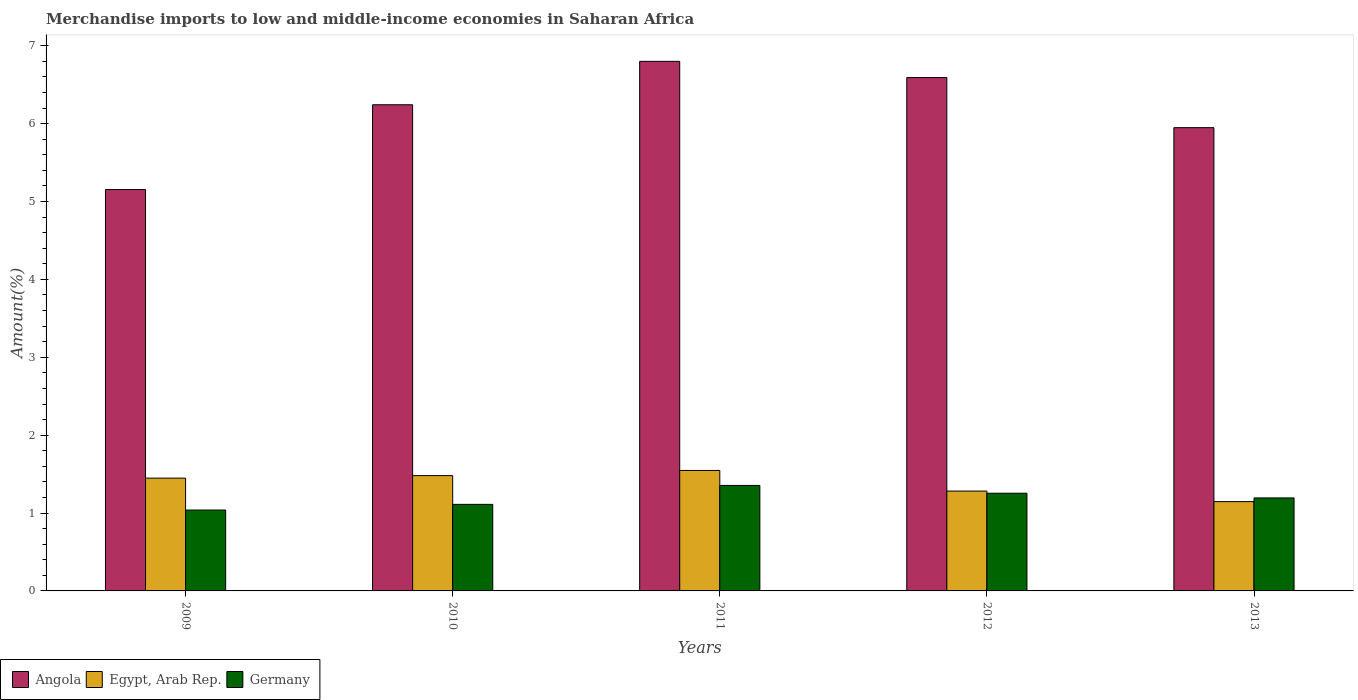How many different coloured bars are there?
Your answer should be very brief. 3. How many groups of bars are there?
Your response must be concise. 5. Are the number of bars per tick equal to the number of legend labels?
Keep it short and to the point. Yes. How many bars are there on the 1st tick from the left?
Offer a very short reply. 3. What is the percentage of amount earned from merchandise imports in Egypt, Arab Rep. in 2011?
Offer a very short reply. 1.55. Across all years, what is the maximum percentage of amount earned from merchandise imports in Egypt, Arab Rep.?
Offer a very short reply. 1.55. Across all years, what is the minimum percentage of amount earned from merchandise imports in Angola?
Keep it short and to the point. 5.15. What is the total percentage of amount earned from merchandise imports in Angola in the graph?
Provide a succinct answer. 30.74. What is the difference between the percentage of amount earned from merchandise imports in Angola in 2010 and that in 2012?
Your answer should be compact. -0.35. What is the difference between the percentage of amount earned from merchandise imports in Germany in 2011 and the percentage of amount earned from merchandise imports in Angola in 2009?
Make the answer very short. -3.8. What is the average percentage of amount earned from merchandise imports in Egypt, Arab Rep. per year?
Give a very brief answer. 1.38. In the year 2010, what is the difference between the percentage of amount earned from merchandise imports in Egypt, Arab Rep. and percentage of amount earned from merchandise imports in Germany?
Give a very brief answer. 0.37. What is the ratio of the percentage of amount earned from merchandise imports in Germany in 2009 to that in 2013?
Provide a succinct answer. 0.87. What is the difference between the highest and the second highest percentage of amount earned from merchandise imports in Angola?
Offer a very short reply. 0.21. What is the difference between the highest and the lowest percentage of amount earned from merchandise imports in Egypt, Arab Rep.?
Ensure brevity in your answer.  0.4. In how many years, is the percentage of amount earned from merchandise imports in Angola greater than the average percentage of amount earned from merchandise imports in Angola taken over all years?
Your response must be concise. 3. What does the 2nd bar from the left in 2012 represents?
Offer a terse response. Egypt, Arab Rep. Does the graph contain any zero values?
Your answer should be very brief. No. What is the title of the graph?
Make the answer very short. Merchandise imports to low and middle-income economies in Saharan Africa. Does "Pacific island small states" appear as one of the legend labels in the graph?
Provide a succinct answer. No. What is the label or title of the X-axis?
Keep it short and to the point. Years. What is the label or title of the Y-axis?
Make the answer very short. Amount(%). What is the Amount(%) of Angola in 2009?
Your answer should be very brief. 5.15. What is the Amount(%) in Egypt, Arab Rep. in 2009?
Ensure brevity in your answer.  1.45. What is the Amount(%) of Germany in 2009?
Your answer should be compact. 1.04. What is the Amount(%) of Angola in 2010?
Your response must be concise. 6.24. What is the Amount(%) of Egypt, Arab Rep. in 2010?
Offer a terse response. 1.48. What is the Amount(%) in Germany in 2010?
Provide a succinct answer. 1.11. What is the Amount(%) of Angola in 2011?
Your answer should be compact. 6.8. What is the Amount(%) in Egypt, Arab Rep. in 2011?
Your response must be concise. 1.55. What is the Amount(%) of Germany in 2011?
Offer a terse response. 1.35. What is the Amount(%) in Angola in 2012?
Your answer should be compact. 6.59. What is the Amount(%) in Egypt, Arab Rep. in 2012?
Offer a terse response. 1.28. What is the Amount(%) in Germany in 2012?
Keep it short and to the point. 1.25. What is the Amount(%) of Angola in 2013?
Offer a terse response. 5.95. What is the Amount(%) of Egypt, Arab Rep. in 2013?
Keep it short and to the point. 1.15. What is the Amount(%) of Germany in 2013?
Ensure brevity in your answer.  1.19. Across all years, what is the maximum Amount(%) in Angola?
Offer a very short reply. 6.8. Across all years, what is the maximum Amount(%) of Egypt, Arab Rep.?
Your response must be concise. 1.55. Across all years, what is the maximum Amount(%) in Germany?
Ensure brevity in your answer.  1.35. Across all years, what is the minimum Amount(%) in Angola?
Keep it short and to the point. 5.15. Across all years, what is the minimum Amount(%) in Egypt, Arab Rep.?
Provide a short and direct response. 1.15. Across all years, what is the minimum Amount(%) in Germany?
Provide a succinct answer. 1.04. What is the total Amount(%) in Angola in the graph?
Ensure brevity in your answer.  30.74. What is the total Amount(%) of Egypt, Arab Rep. in the graph?
Make the answer very short. 6.91. What is the total Amount(%) of Germany in the graph?
Give a very brief answer. 5.95. What is the difference between the Amount(%) in Angola in 2009 and that in 2010?
Your answer should be compact. -1.09. What is the difference between the Amount(%) of Egypt, Arab Rep. in 2009 and that in 2010?
Give a very brief answer. -0.03. What is the difference between the Amount(%) in Germany in 2009 and that in 2010?
Provide a short and direct response. -0.07. What is the difference between the Amount(%) of Angola in 2009 and that in 2011?
Offer a very short reply. -1.65. What is the difference between the Amount(%) of Egypt, Arab Rep. in 2009 and that in 2011?
Your answer should be compact. -0.1. What is the difference between the Amount(%) in Germany in 2009 and that in 2011?
Offer a terse response. -0.32. What is the difference between the Amount(%) in Angola in 2009 and that in 2012?
Your answer should be compact. -1.44. What is the difference between the Amount(%) in Egypt, Arab Rep. in 2009 and that in 2012?
Your response must be concise. 0.17. What is the difference between the Amount(%) of Germany in 2009 and that in 2012?
Offer a very short reply. -0.22. What is the difference between the Amount(%) of Angola in 2009 and that in 2013?
Make the answer very short. -0.79. What is the difference between the Amount(%) of Egypt, Arab Rep. in 2009 and that in 2013?
Your answer should be compact. 0.3. What is the difference between the Amount(%) of Germany in 2009 and that in 2013?
Provide a short and direct response. -0.16. What is the difference between the Amount(%) in Angola in 2010 and that in 2011?
Your answer should be compact. -0.56. What is the difference between the Amount(%) in Egypt, Arab Rep. in 2010 and that in 2011?
Give a very brief answer. -0.07. What is the difference between the Amount(%) of Germany in 2010 and that in 2011?
Provide a succinct answer. -0.24. What is the difference between the Amount(%) in Angola in 2010 and that in 2012?
Keep it short and to the point. -0.35. What is the difference between the Amount(%) in Egypt, Arab Rep. in 2010 and that in 2012?
Give a very brief answer. 0.2. What is the difference between the Amount(%) in Germany in 2010 and that in 2012?
Ensure brevity in your answer.  -0.14. What is the difference between the Amount(%) of Angola in 2010 and that in 2013?
Offer a very short reply. 0.29. What is the difference between the Amount(%) in Egypt, Arab Rep. in 2010 and that in 2013?
Provide a succinct answer. 0.33. What is the difference between the Amount(%) in Germany in 2010 and that in 2013?
Provide a succinct answer. -0.08. What is the difference between the Amount(%) of Angola in 2011 and that in 2012?
Provide a succinct answer. 0.21. What is the difference between the Amount(%) in Egypt, Arab Rep. in 2011 and that in 2012?
Provide a succinct answer. 0.26. What is the difference between the Amount(%) of Germany in 2011 and that in 2012?
Offer a terse response. 0.1. What is the difference between the Amount(%) in Angola in 2011 and that in 2013?
Provide a succinct answer. 0.85. What is the difference between the Amount(%) in Germany in 2011 and that in 2013?
Offer a terse response. 0.16. What is the difference between the Amount(%) of Angola in 2012 and that in 2013?
Provide a short and direct response. 0.64. What is the difference between the Amount(%) of Egypt, Arab Rep. in 2012 and that in 2013?
Keep it short and to the point. 0.14. What is the difference between the Amount(%) in Germany in 2012 and that in 2013?
Your response must be concise. 0.06. What is the difference between the Amount(%) of Angola in 2009 and the Amount(%) of Egypt, Arab Rep. in 2010?
Your answer should be compact. 3.67. What is the difference between the Amount(%) in Angola in 2009 and the Amount(%) in Germany in 2010?
Provide a short and direct response. 4.04. What is the difference between the Amount(%) of Egypt, Arab Rep. in 2009 and the Amount(%) of Germany in 2010?
Offer a terse response. 0.34. What is the difference between the Amount(%) in Angola in 2009 and the Amount(%) in Egypt, Arab Rep. in 2011?
Offer a very short reply. 3.61. What is the difference between the Amount(%) in Angola in 2009 and the Amount(%) in Germany in 2011?
Your answer should be compact. 3.8. What is the difference between the Amount(%) in Egypt, Arab Rep. in 2009 and the Amount(%) in Germany in 2011?
Provide a succinct answer. 0.09. What is the difference between the Amount(%) of Angola in 2009 and the Amount(%) of Egypt, Arab Rep. in 2012?
Offer a very short reply. 3.87. What is the difference between the Amount(%) in Angola in 2009 and the Amount(%) in Germany in 2012?
Give a very brief answer. 3.9. What is the difference between the Amount(%) of Egypt, Arab Rep. in 2009 and the Amount(%) of Germany in 2012?
Ensure brevity in your answer.  0.19. What is the difference between the Amount(%) in Angola in 2009 and the Amount(%) in Egypt, Arab Rep. in 2013?
Give a very brief answer. 4.01. What is the difference between the Amount(%) of Angola in 2009 and the Amount(%) of Germany in 2013?
Your answer should be very brief. 3.96. What is the difference between the Amount(%) in Egypt, Arab Rep. in 2009 and the Amount(%) in Germany in 2013?
Offer a terse response. 0.25. What is the difference between the Amount(%) in Angola in 2010 and the Amount(%) in Egypt, Arab Rep. in 2011?
Keep it short and to the point. 4.7. What is the difference between the Amount(%) of Angola in 2010 and the Amount(%) of Germany in 2011?
Your answer should be very brief. 4.89. What is the difference between the Amount(%) of Egypt, Arab Rep. in 2010 and the Amount(%) of Germany in 2011?
Your answer should be compact. 0.13. What is the difference between the Amount(%) of Angola in 2010 and the Amount(%) of Egypt, Arab Rep. in 2012?
Provide a short and direct response. 4.96. What is the difference between the Amount(%) of Angola in 2010 and the Amount(%) of Germany in 2012?
Ensure brevity in your answer.  4.99. What is the difference between the Amount(%) in Egypt, Arab Rep. in 2010 and the Amount(%) in Germany in 2012?
Offer a very short reply. 0.23. What is the difference between the Amount(%) in Angola in 2010 and the Amount(%) in Egypt, Arab Rep. in 2013?
Provide a short and direct response. 5.1. What is the difference between the Amount(%) of Angola in 2010 and the Amount(%) of Germany in 2013?
Provide a short and direct response. 5.05. What is the difference between the Amount(%) in Egypt, Arab Rep. in 2010 and the Amount(%) in Germany in 2013?
Provide a succinct answer. 0.29. What is the difference between the Amount(%) in Angola in 2011 and the Amount(%) in Egypt, Arab Rep. in 2012?
Provide a succinct answer. 5.52. What is the difference between the Amount(%) in Angola in 2011 and the Amount(%) in Germany in 2012?
Your answer should be very brief. 5.55. What is the difference between the Amount(%) of Egypt, Arab Rep. in 2011 and the Amount(%) of Germany in 2012?
Make the answer very short. 0.29. What is the difference between the Amount(%) of Angola in 2011 and the Amount(%) of Egypt, Arab Rep. in 2013?
Ensure brevity in your answer.  5.65. What is the difference between the Amount(%) of Angola in 2011 and the Amount(%) of Germany in 2013?
Provide a short and direct response. 5.61. What is the difference between the Amount(%) in Egypt, Arab Rep. in 2011 and the Amount(%) in Germany in 2013?
Give a very brief answer. 0.35. What is the difference between the Amount(%) in Angola in 2012 and the Amount(%) in Egypt, Arab Rep. in 2013?
Provide a succinct answer. 5.44. What is the difference between the Amount(%) of Angola in 2012 and the Amount(%) of Germany in 2013?
Make the answer very short. 5.4. What is the difference between the Amount(%) of Egypt, Arab Rep. in 2012 and the Amount(%) of Germany in 2013?
Your response must be concise. 0.09. What is the average Amount(%) of Angola per year?
Your answer should be very brief. 6.15. What is the average Amount(%) of Egypt, Arab Rep. per year?
Make the answer very short. 1.38. What is the average Amount(%) in Germany per year?
Your answer should be very brief. 1.19. In the year 2009, what is the difference between the Amount(%) of Angola and Amount(%) of Egypt, Arab Rep.?
Your answer should be very brief. 3.71. In the year 2009, what is the difference between the Amount(%) in Angola and Amount(%) in Germany?
Make the answer very short. 4.12. In the year 2009, what is the difference between the Amount(%) in Egypt, Arab Rep. and Amount(%) in Germany?
Offer a terse response. 0.41. In the year 2010, what is the difference between the Amount(%) in Angola and Amount(%) in Egypt, Arab Rep.?
Provide a short and direct response. 4.76. In the year 2010, what is the difference between the Amount(%) in Angola and Amount(%) in Germany?
Give a very brief answer. 5.13. In the year 2010, what is the difference between the Amount(%) of Egypt, Arab Rep. and Amount(%) of Germany?
Provide a short and direct response. 0.37. In the year 2011, what is the difference between the Amount(%) in Angola and Amount(%) in Egypt, Arab Rep.?
Offer a terse response. 5.25. In the year 2011, what is the difference between the Amount(%) of Angola and Amount(%) of Germany?
Your answer should be compact. 5.45. In the year 2011, what is the difference between the Amount(%) of Egypt, Arab Rep. and Amount(%) of Germany?
Provide a succinct answer. 0.19. In the year 2012, what is the difference between the Amount(%) of Angola and Amount(%) of Egypt, Arab Rep.?
Give a very brief answer. 5.31. In the year 2012, what is the difference between the Amount(%) of Angola and Amount(%) of Germany?
Offer a very short reply. 5.34. In the year 2012, what is the difference between the Amount(%) in Egypt, Arab Rep. and Amount(%) in Germany?
Keep it short and to the point. 0.03. In the year 2013, what is the difference between the Amount(%) in Angola and Amount(%) in Egypt, Arab Rep.?
Your answer should be compact. 4.8. In the year 2013, what is the difference between the Amount(%) in Angola and Amount(%) in Germany?
Keep it short and to the point. 4.75. In the year 2013, what is the difference between the Amount(%) of Egypt, Arab Rep. and Amount(%) of Germany?
Keep it short and to the point. -0.05. What is the ratio of the Amount(%) of Angola in 2009 to that in 2010?
Your answer should be very brief. 0.83. What is the ratio of the Amount(%) in Egypt, Arab Rep. in 2009 to that in 2010?
Offer a terse response. 0.98. What is the ratio of the Amount(%) of Germany in 2009 to that in 2010?
Provide a succinct answer. 0.93. What is the ratio of the Amount(%) of Angola in 2009 to that in 2011?
Give a very brief answer. 0.76. What is the ratio of the Amount(%) in Egypt, Arab Rep. in 2009 to that in 2011?
Give a very brief answer. 0.94. What is the ratio of the Amount(%) of Germany in 2009 to that in 2011?
Offer a terse response. 0.77. What is the ratio of the Amount(%) of Angola in 2009 to that in 2012?
Your response must be concise. 0.78. What is the ratio of the Amount(%) of Egypt, Arab Rep. in 2009 to that in 2012?
Ensure brevity in your answer.  1.13. What is the ratio of the Amount(%) in Germany in 2009 to that in 2012?
Give a very brief answer. 0.83. What is the ratio of the Amount(%) of Angola in 2009 to that in 2013?
Your answer should be very brief. 0.87. What is the ratio of the Amount(%) in Egypt, Arab Rep. in 2009 to that in 2013?
Make the answer very short. 1.26. What is the ratio of the Amount(%) in Germany in 2009 to that in 2013?
Offer a very short reply. 0.87. What is the ratio of the Amount(%) in Angola in 2010 to that in 2011?
Give a very brief answer. 0.92. What is the ratio of the Amount(%) of Egypt, Arab Rep. in 2010 to that in 2011?
Your answer should be compact. 0.96. What is the ratio of the Amount(%) in Germany in 2010 to that in 2011?
Ensure brevity in your answer.  0.82. What is the ratio of the Amount(%) of Angola in 2010 to that in 2012?
Your answer should be very brief. 0.95. What is the ratio of the Amount(%) of Egypt, Arab Rep. in 2010 to that in 2012?
Make the answer very short. 1.15. What is the ratio of the Amount(%) in Germany in 2010 to that in 2012?
Provide a short and direct response. 0.89. What is the ratio of the Amount(%) of Angola in 2010 to that in 2013?
Ensure brevity in your answer.  1.05. What is the ratio of the Amount(%) of Egypt, Arab Rep. in 2010 to that in 2013?
Your answer should be compact. 1.29. What is the ratio of the Amount(%) of Germany in 2010 to that in 2013?
Your answer should be compact. 0.93. What is the ratio of the Amount(%) of Angola in 2011 to that in 2012?
Offer a very short reply. 1.03. What is the ratio of the Amount(%) of Egypt, Arab Rep. in 2011 to that in 2012?
Ensure brevity in your answer.  1.21. What is the ratio of the Amount(%) in Germany in 2011 to that in 2012?
Ensure brevity in your answer.  1.08. What is the ratio of the Amount(%) of Angola in 2011 to that in 2013?
Your answer should be very brief. 1.14. What is the ratio of the Amount(%) of Egypt, Arab Rep. in 2011 to that in 2013?
Give a very brief answer. 1.35. What is the ratio of the Amount(%) in Germany in 2011 to that in 2013?
Your answer should be compact. 1.13. What is the ratio of the Amount(%) of Angola in 2012 to that in 2013?
Provide a succinct answer. 1.11. What is the ratio of the Amount(%) of Egypt, Arab Rep. in 2012 to that in 2013?
Offer a very short reply. 1.12. What is the ratio of the Amount(%) in Germany in 2012 to that in 2013?
Offer a very short reply. 1.05. What is the difference between the highest and the second highest Amount(%) of Angola?
Offer a terse response. 0.21. What is the difference between the highest and the second highest Amount(%) of Egypt, Arab Rep.?
Your response must be concise. 0.07. What is the difference between the highest and the second highest Amount(%) in Germany?
Your answer should be compact. 0.1. What is the difference between the highest and the lowest Amount(%) in Angola?
Offer a terse response. 1.65. What is the difference between the highest and the lowest Amount(%) in Germany?
Make the answer very short. 0.32. 